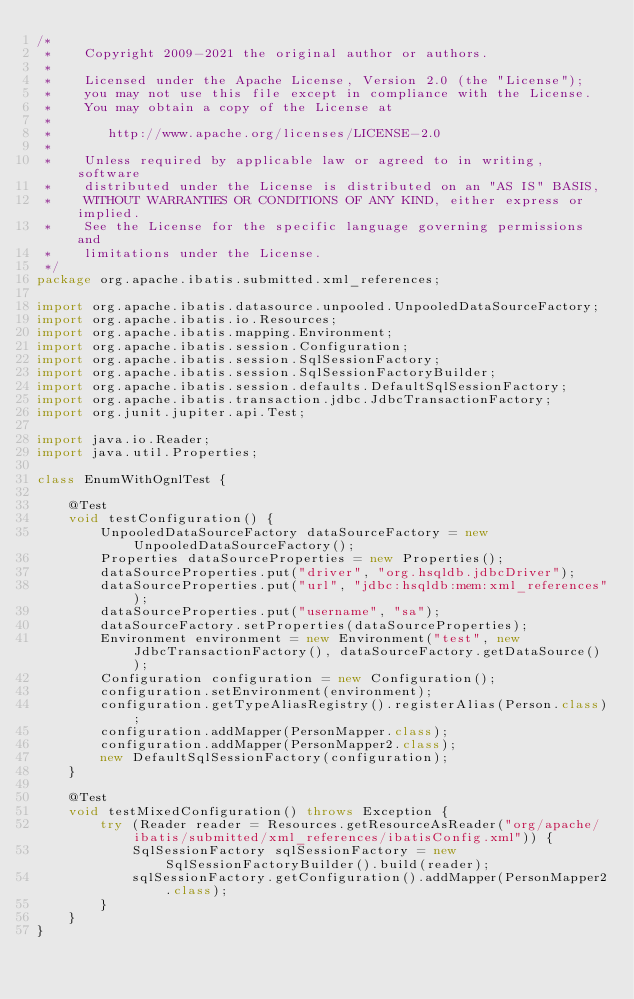Convert code to text. <code><loc_0><loc_0><loc_500><loc_500><_Java_>/*
 *    Copyright 2009-2021 the original author or authors.
 *
 *    Licensed under the Apache License, Version 2.0 (the "License");
 *    you may not use this file except in compliance with the License.
 *    You may obtain a copy of the License at
 *
 *       http://www.apache.org/licenses/LICENSE-2.0
 *
 *    Unless required by applicable law or agreed to in writing, software
 *    distributed under the License is distributed on an "AS IS" BASIS,
 *    WITHOUT WARRANTIES OR CONDITIONS OF ANY KIND, either express or implied.
 *    See the License for the specific language governing permissions and
 *    limitations under the License.
 */
package org.apache.ibatis.submitted.xml_references;

import org.apache.ibatis.datasource.unpooled.UnpooledDataSourceFactory;
import org.apache.ibatis.io.Resources;
import org.apache.ibatis.mapping.Environment;
import org.apache.ibatis.session.Configuration;
import org.apache.ibatis.session.SqlSessionFactory;
import org.apache.ibatis.session.SqlSessionFactoryBuilder;
import org.apache.ibatis.session.defaults.DefaultSqlSessionFactory;
import org.apache.ibatis.transaction.jdbc.JdbcTransactionFactory;
import org.junit.jupiter.api.Test;

import java.io.Reader;
import java.util.Properties;

class EnumWithOgnlTest {

    @Test
    void testConfiguration() {
        UnpooledDataSourceFactory dataSourceFactory = new UnpooledDataSourceFactory();
        Properties dataSourceProperties = new Properties();
        dataSourceProperties.put("driver", "org.hsqldb.jdbcDriver");
        dataSourceProperties.put("url", "jdbc:hsqldb:mem:xml_references");
        dataSourceProperties.put("username", "sa");
        dataSourceFactory.setProperties(dataSourceProperties);
        Environment environment = new Environment("test", new JdbcTransactionFactory(), dataSourceFactory.getDataSource());
        Configuration configuration = new Configuration();
        configuration.setEnvironment(environment);
        configuration.getTypeAliasRegistry().registerAlias(Person.class);
        configuration.addMapper(PersonMapper.class);
        configuration.addMapper(PersonMapper2.class);
        new DefaultSqlSessionFactory(configuration);
    }

    @Test
    void testMixedConfiguration() throws Exception {
        try (Reader reader = Resources.getResourceAsReader("org/apache/ibatis/submitted/xml_references/ibatisConfig.xml")) {
            SqlSessionFactory sqlSessionFactory = new SqlSessionFactoryBuilder().build(reader);
            sqlSessionFactory.getConfiguration().addMapper(PersonMapper2.class);
        }
    }
}
</code> 